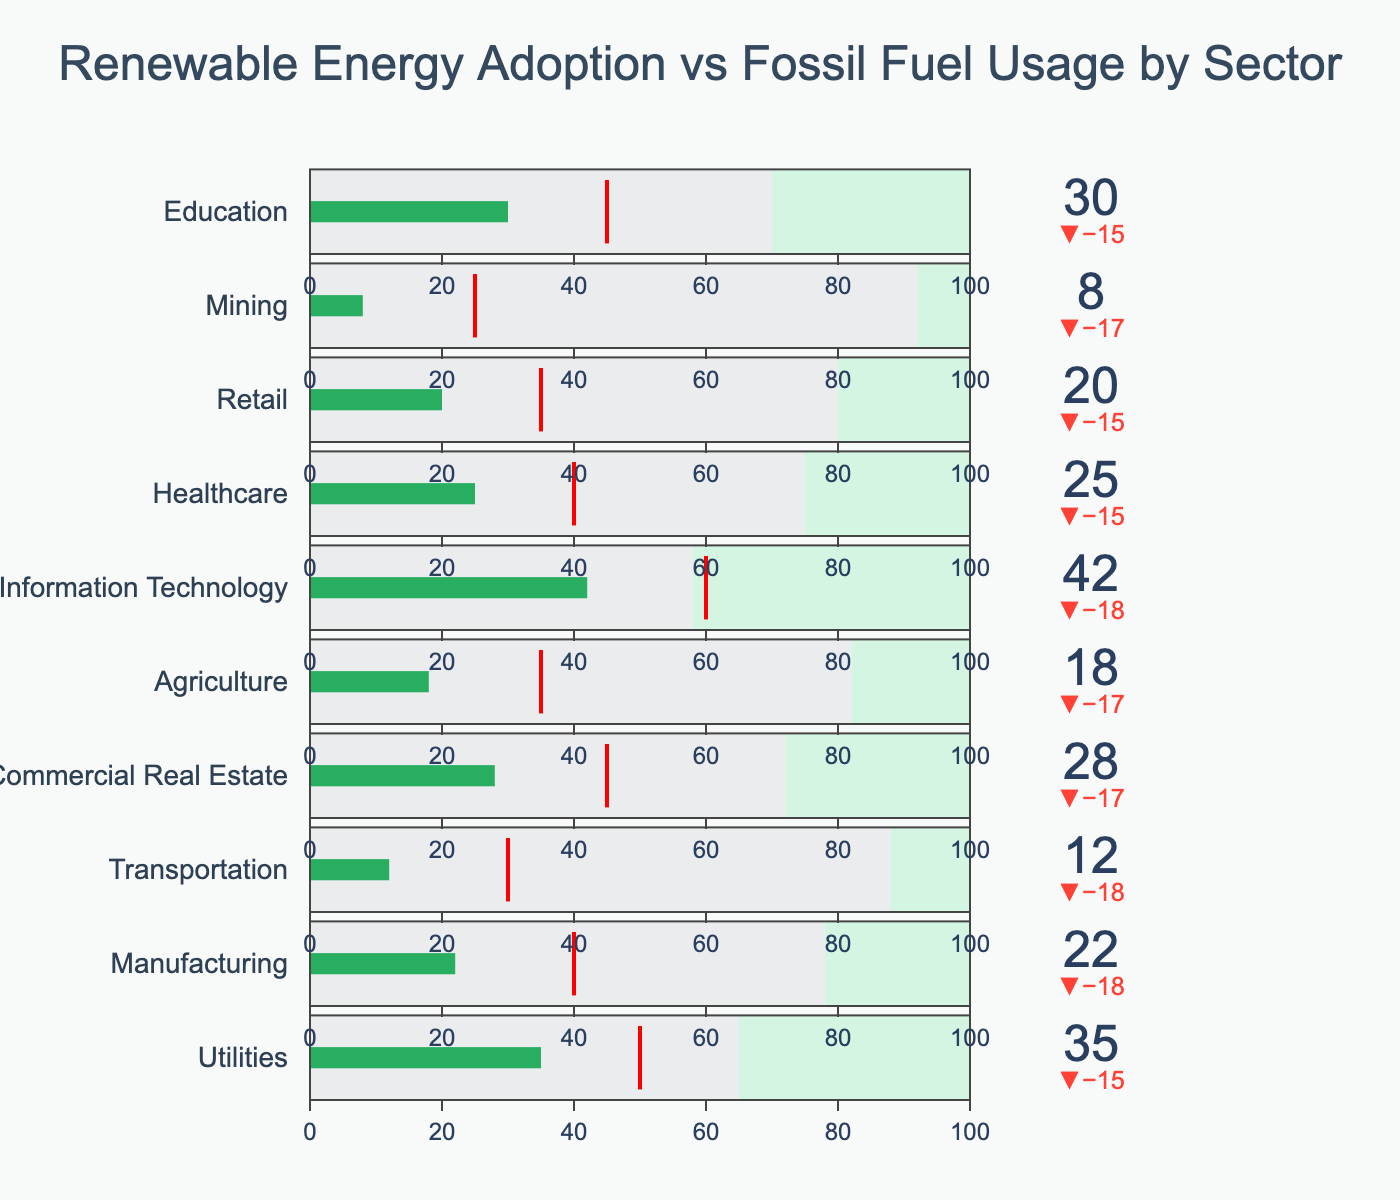What is the title of the chart? The title is usually displayed at the top of the chart and provides a brief description of what the chart represents. In this case, it is the large text centered at the top.
Answer: Renewable Energy Adoption vs Fossil Fuel Usage by Sector What is the renewable adoption percentage for the Utilities sector? To find this, locate the Utilities sector in the chart and look at the value displayed for Renewable Adoption which is typically represented in the bar section of the bullet chart.
Answer: 35% Which sector has the highest renewable adoption percentage? Scan through all the sectors and compare their Renewable Adoption percentages. Identify the sector with the largest percentage value.
Answer: Information Technology Is the renewable adoption for the Transportation sector above or below the target? Check the position of the renewable adoption bar for Transportation relative to the red threshold line (which indicates the target).
Answer: Below the target What is the difference between the renewable adoption percentage and the target for the Education sector? First, find the renewable adoption percentage and the target percentage for Education. Calculate the difference by subtracting the target from the renewable adoption percentage.
Answer: -15% (30% - 45%) Which sector has the lowest fossil fuel usage percentage? Scan through all the sectors and compare their Fossil Fuel Usage percentages. Identify the sector with the smallest percentage value.
Answer: Information Technology How many sectors have renewable adoption values below their targets? For each sector, check if the renewable adoption percentage is less than the target percentage (by comparing the renewable adoption value with the position of the red line). Count the number of such sectors.
Answer: 8 sectors What is the average renewable adoption percentage for all sectors combined? Sum up all the renewable adoption percentages for each sector, and then divide by the total number of sectors. (35+22+12+28+18+42+25+20+8+30)/10 = 24
Answer: 24% Which sector shows the largest gap between renewable adoption and fossil fuel usage? For each sector, calculate the absolute difference between renewable adoption and fossil fuel usage. Identify the sector with the largest difference.
Answer: Mining How does the renewable adoption of Commercial Real Estate compare to Agriculture? Check the renewable adoption percentages for both sectors from the chart and compare them.
Answer: Commercial Real Estate has a higher renewable adoption (28% vs 18%) 